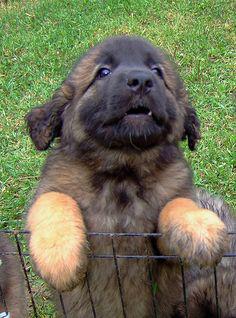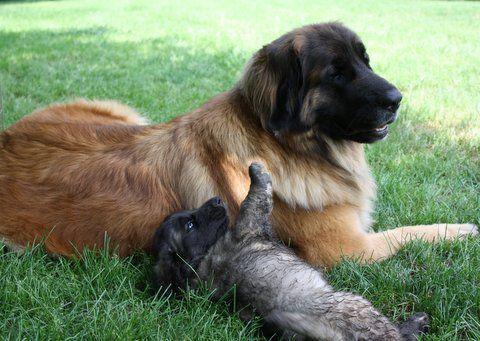The first image is the image on the left, the second image is the image on the right. Assess this claim about the two images: "One image features two dogs, and adult and a puppy, in an outdoor setting.". Correct or not? Answer yes or no. Yes. The first image is the image on the left, the second image is the image on the right. Assess this claim about the two images: "An image shows one big dog and one small dog outdoors.". Correct or not? Answer yes or no. Yes. 